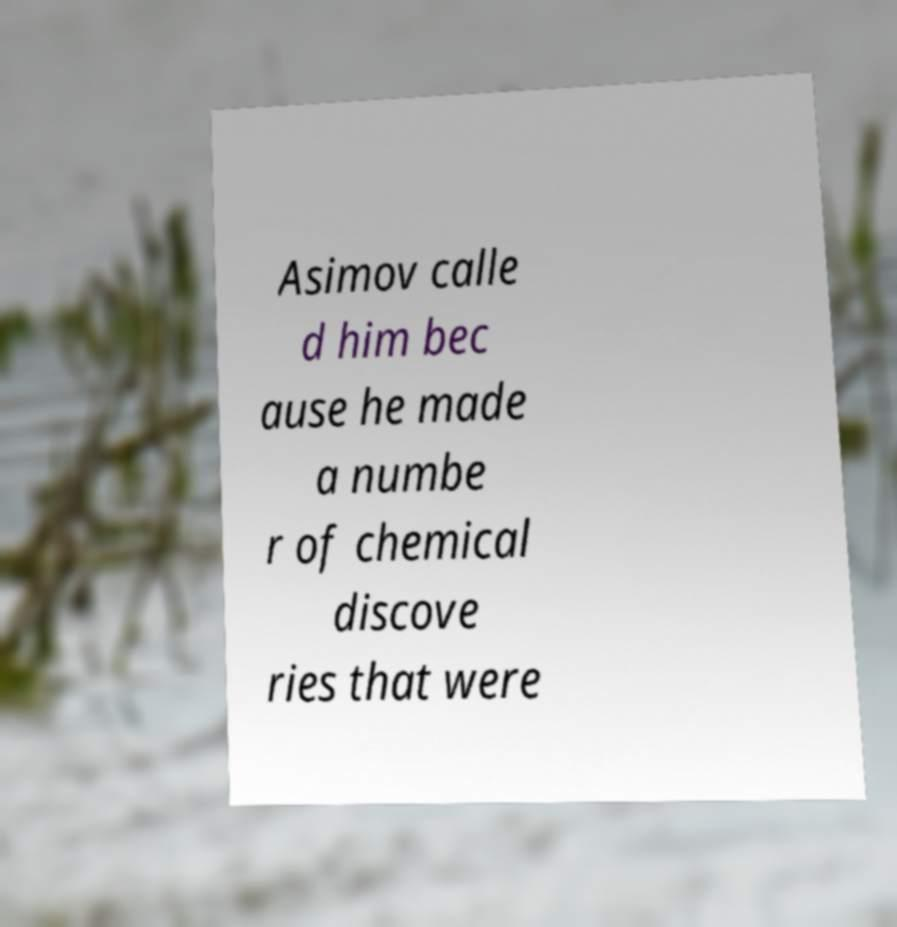Can you accurately transcribe the text from the provided image for me? Asimov calle d him bec ause he made a numbe r of chemical discove ries that were 